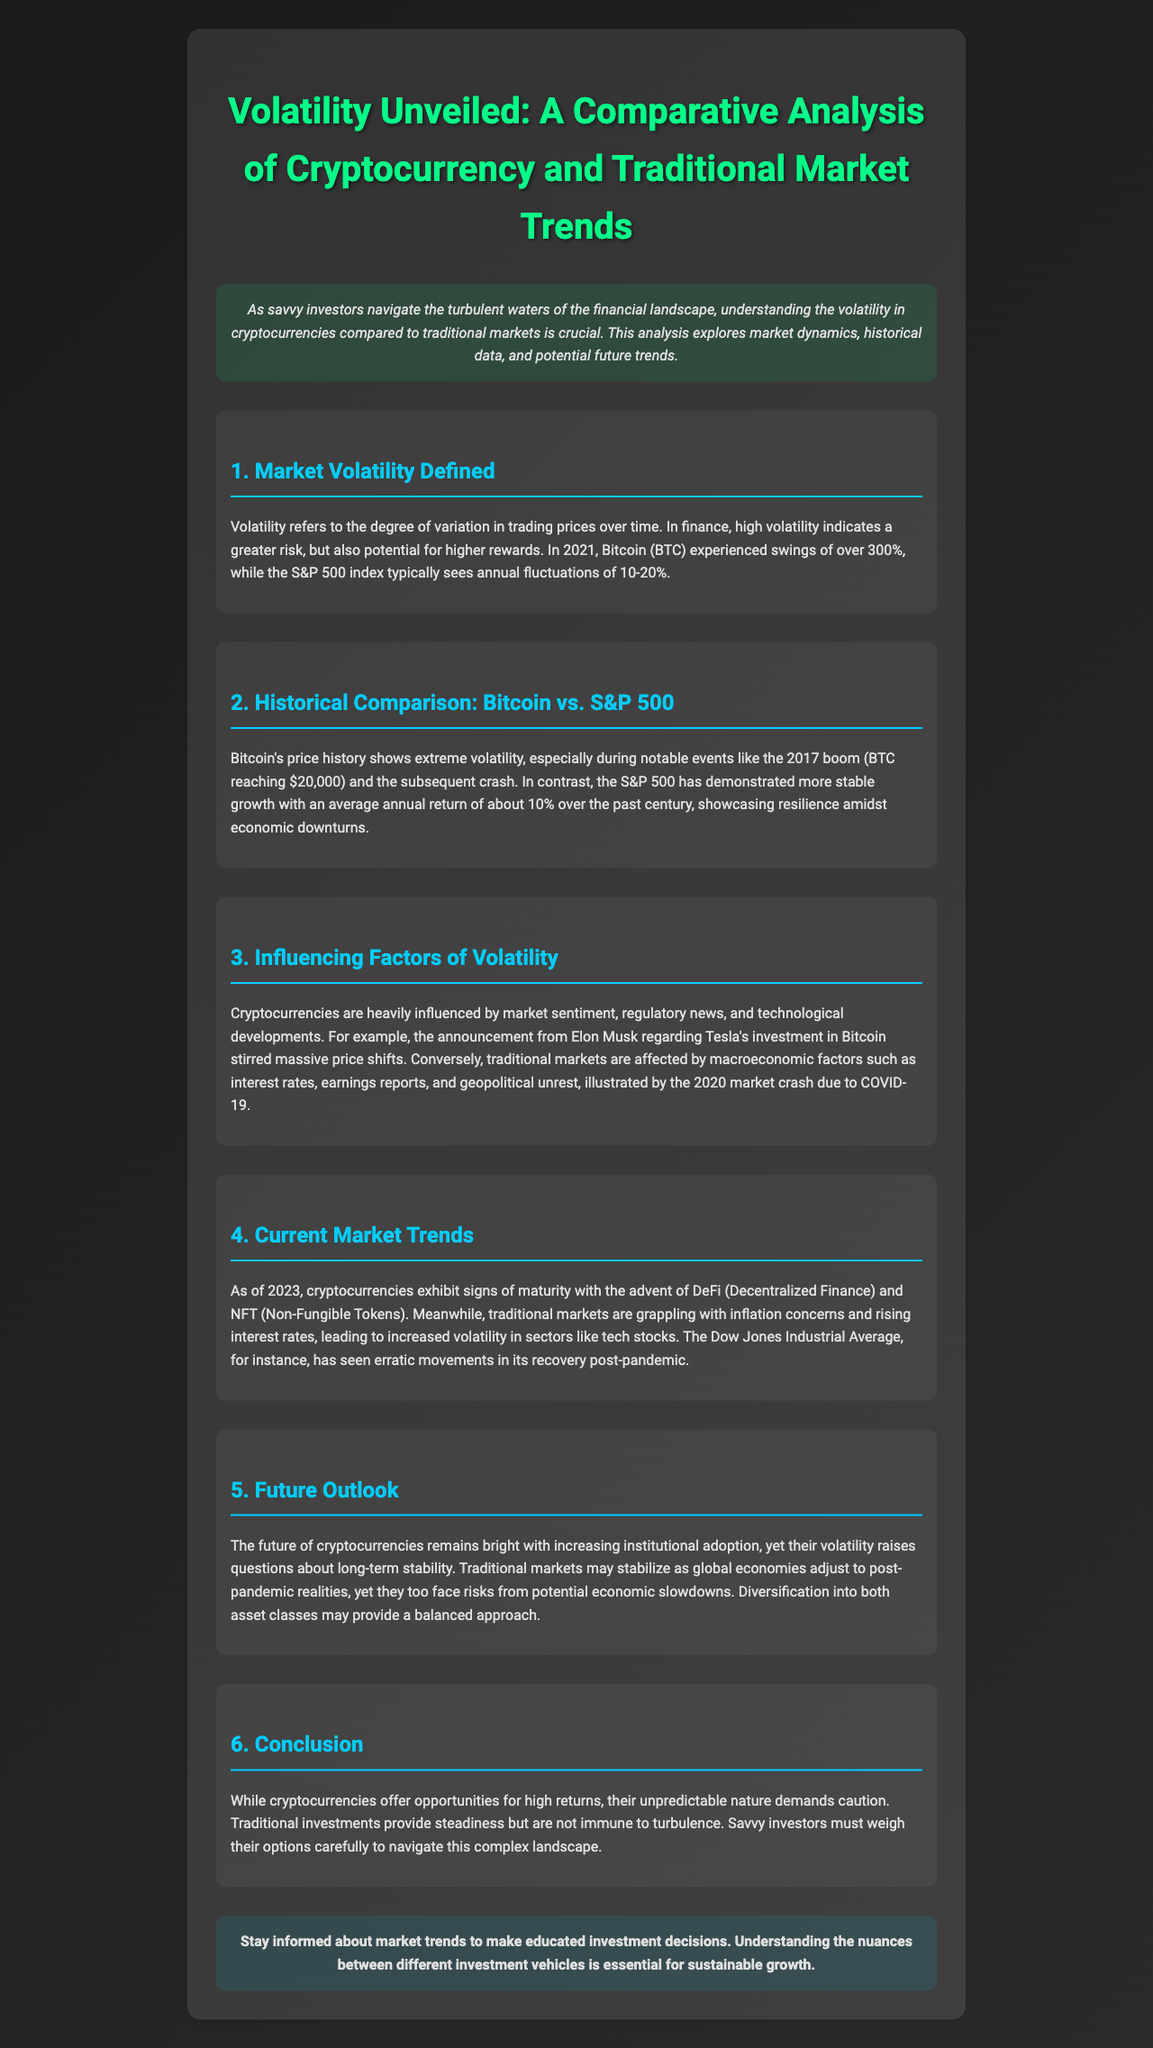What is the main topic of the newsletter? The main topic of the newsletter is about the volatility in cryptocurrencies compared to traditional markets.
Answer: Volatility Unveiled: A Comparative Analysis of Cryptocurrency and Traditional Market Trends What percentage of annual fluctuations does the S&P 500 typically see? The document states that the S&P 500 index typically sees annual fluctuations of 10-20%.
Answer: 10-20% In what year did Bitcoin reach $20,000? The document mentions this significant event during the 2017 boom.
Answer: 2017 What are two factors that influence cryptocurrency volatility? The document mentions market sentiment and regulatory news as influencing factors.
Answer: Market sentiment, regulatory news What has been the average annual return of the S&P 500 over the past century? The average annual return of the S&P 500 is about 10%.
Answer: 10% As of 2023, what trends are cryptocurrencies showing? The document states that cryptocurrencies exhibit signs of maturity with the advent of DeFi and NFTs.
Answer: Maturity with DeFi and NFTs What economic concern is affecting traditional markets as of 2023? The document indicates that traditional markets are grappling with inflation concerns.
Answer: Inflation concerns What is a potential strategy for investors mentioned in the conclusion? The conclusion suggests that diversification into both asset classes may provide a balanced approach.
Answer: Diversification into both asset classes 